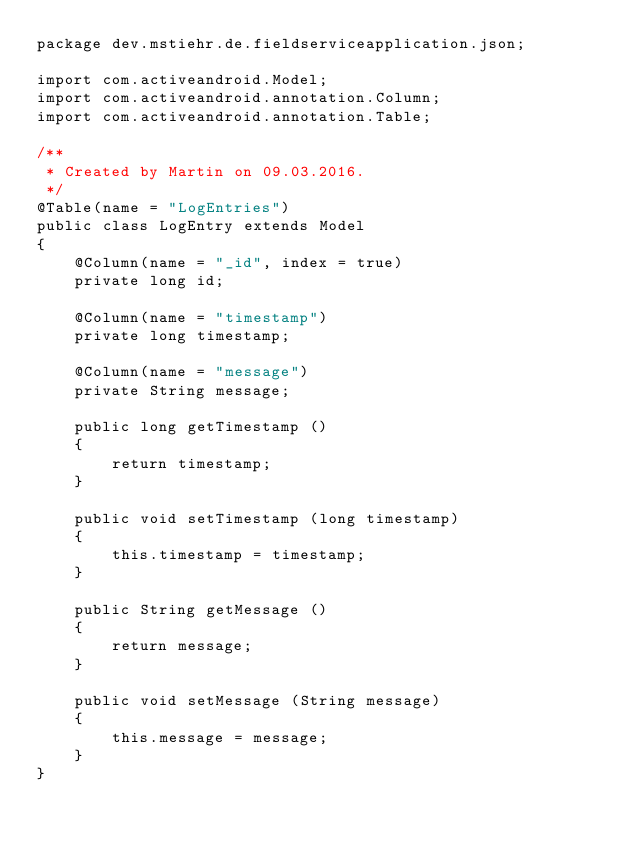Convert code to text. <code><loc_0><loc_0><loc_500><loc_500><_Java_>package dev.mstiehr.de.fieldserviceapplication.json;

import com.activeandroid.Model;
import com.activeandroid.annotation.Column;
import com.activeandroid.annotation.Table;

/**
 * Created by Martin on 09.03.2016.
 */
@Table(name = "LogEntries")
public class LogEntry extends Model
{
    @Column(name = "_id", index = true)
    private long id;

    @Column(name = "timestamp")
    private long timestamp;

    @Column(name = "message")
    private String message;

    public long getTimestamp ()
    {
        return timestamp;
    }

    public void setTimestamp (long timestamp)
    {
        this.timestamp = timestamp;
    }

    public String getMessage ()
    {
        return message;
    }

    public void setMessage (String message)
    {
        this.message = message;
    }
}
</code> 